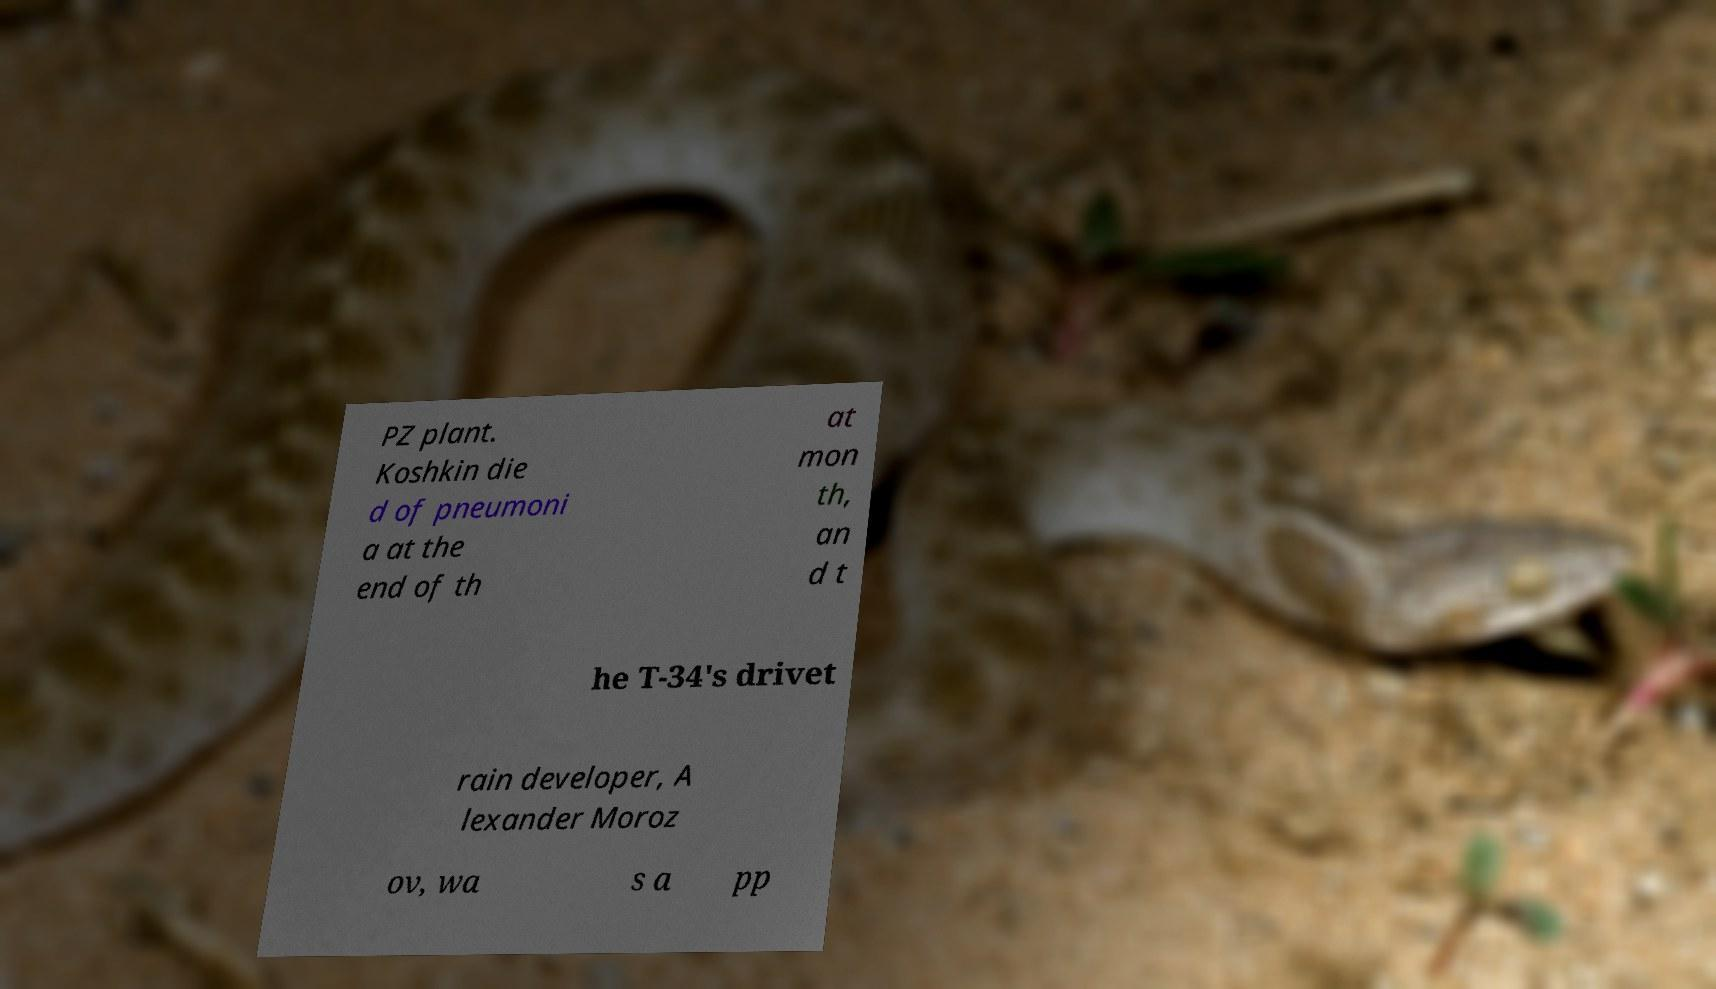Please identify and transcribe the text found in this image. PZ plant. Koshkin die d of pneumoni a at the end of th at mon th, an d t he T-34's drivet rain developer, A lexander Moroz ov, wa s a pp 